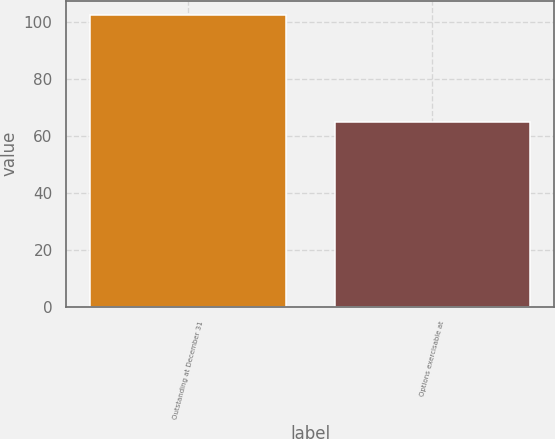Convert chart to OTSL. <chart><loc_0><loc_0><loc_500><loc_500><bar_chart><fcel>Outstanding at December 31<fcel>Options exercisable at<nl><fcel>102.3<fcel>64.7<nl></chart> 